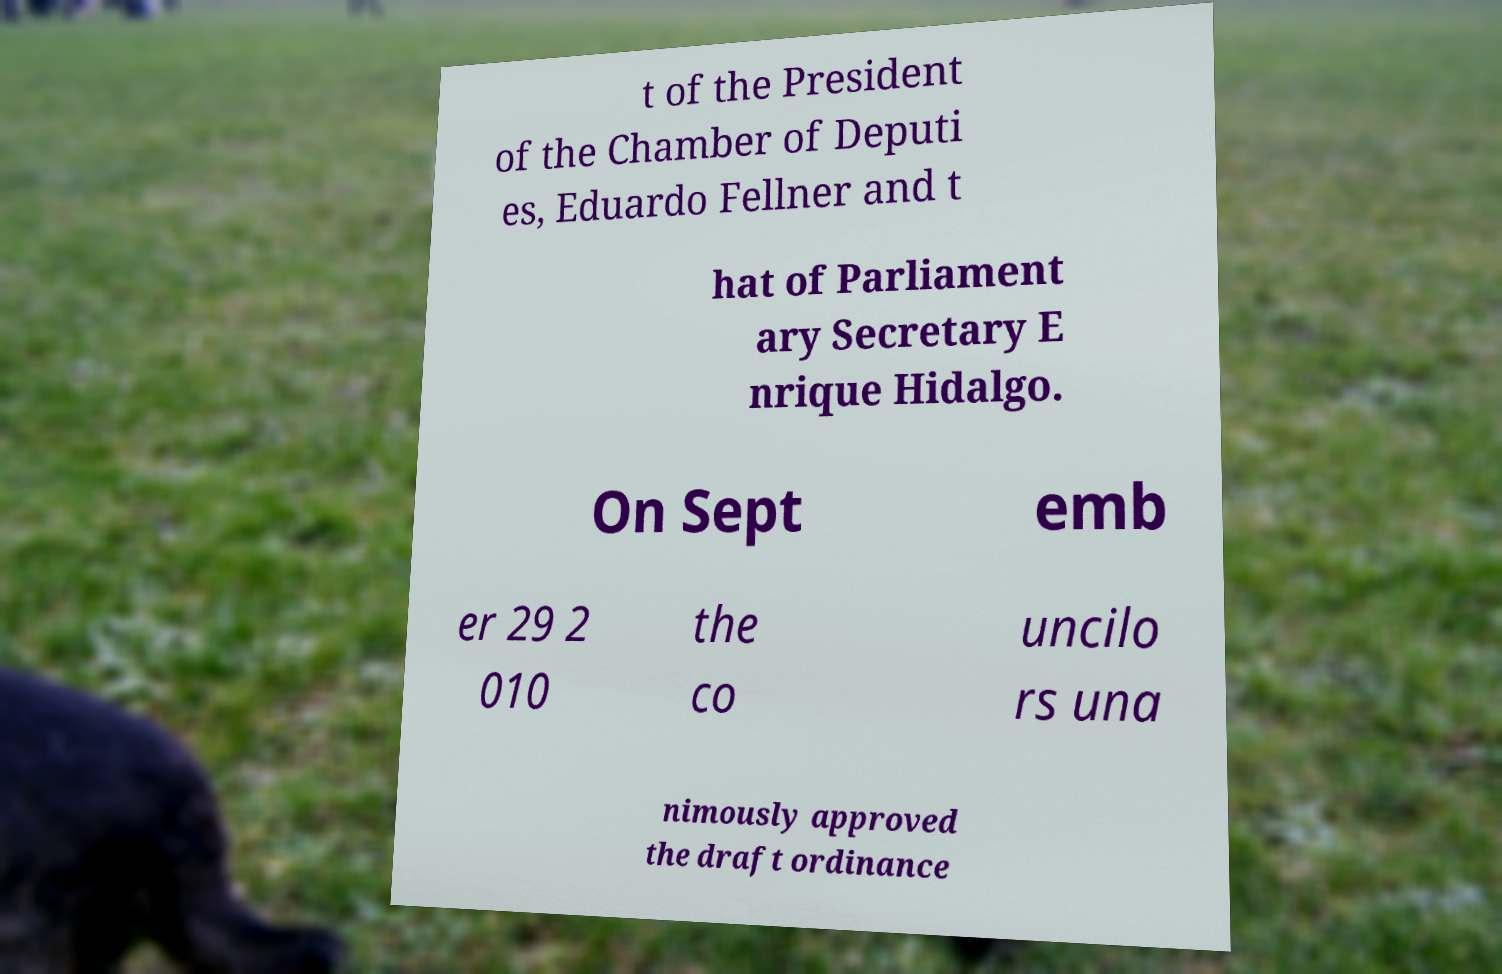Can you accurately transcribe the text from the provided image for me? t of the President of the Chamber of Deputi es, Eduardo Fellner and t hat of Parliament ary Secretary E nrique Hidalgo. On Sept emb er 29 2 010 the co uncilo rs una nimously approved the draft ordinance 